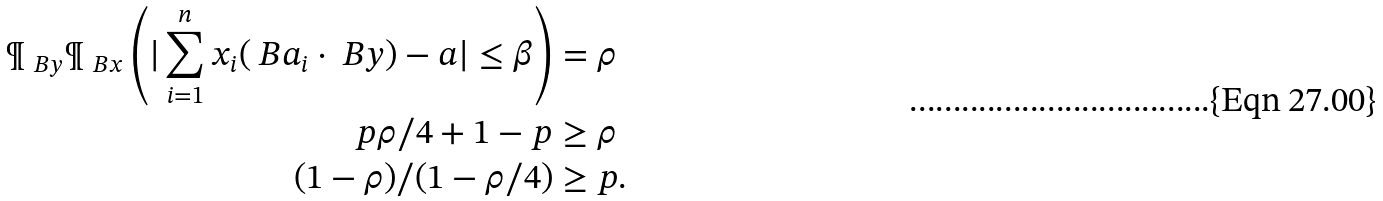Convert formula to latex. <formula><loc_0><loc_0><loc_500><loc_500>\P _ { \ B y } \P _ { \ B x } \left ( | \sum _ { i = 1 } ^ { n } x _ { i } ( \ B a _ { i } \cdot \ B y ) - a | \leq \beta \right ) & = \rho \\ p \rho / 4 + 1 - p & \geq \rho \\ ( 1 - \rho ) / ( 1 - \rho / 4 ) & \geq p .</formula> 